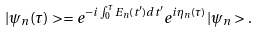Convert formula to latex. <formula><loc_0><loc_0><loc_500><loc_500>| \psi _ { n } ( \tau ) > = e ^ { - i \int _ { 0 } ^ { \tau } E _ { n } ( t ^ { \prime } ) d t ^ { \prime } } e ^ { i \eta _ { n } ( \tau ) } | \psi _ { n } > .</formula> 